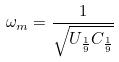Convert formula to latex. <formula><loc_0><loc_0><loc_500><loc_500>\omega _ { m } = \frac { 1 } { \sqrt { U _ { \frac { 1 } { 9 } } C _ { \frac { 1 } { 9 } } } }</formula> 